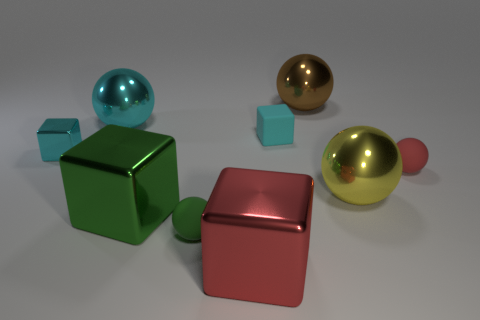Subtract all large brown balls. How many balls are left? 4 Subtract 4 spheres. How many spheres are left? 1 Subtract all cyan balls. How many balls are left? 4 Subtract all cubes. How many objects are left? 5 Add 7 big red blocks. How many big red blocks are left? 8 Add 3 big red shiny things. How many big red shiny things exist? 4 Subtract 1 brown spheres. How many objects are left? 8 Subtract all red spheres. Subtract all yellow cubes. How many spheres are left? 4 Subtract all yellow spheres. How many cyan cubes are left? 2 Subtract all red blocks. Subtract all red blocks. How many objects are left? 7 